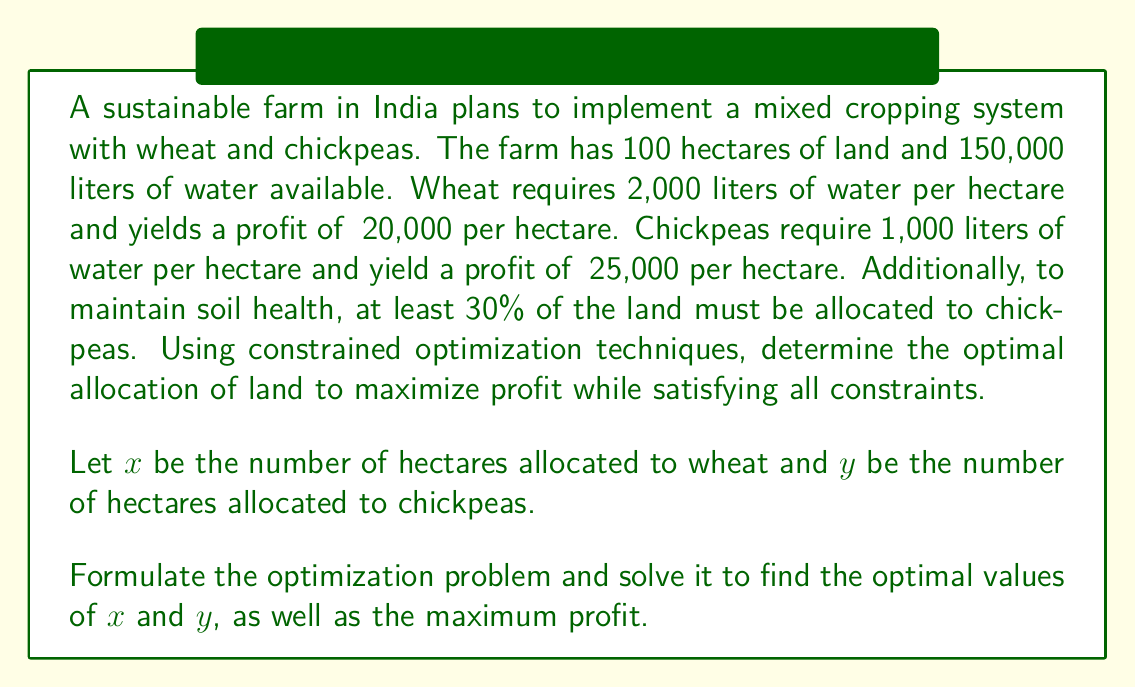Provide a solution to this math problem. To solve this problem, we'll use linear programming, a constrained optimization technique. Let's follow these steps:

1. Formulate the objective function:
   Maximize profit: $Z = 20000x + 25000y$

2. Identify the constraints:
   a) Land constraint: $x + y \leq 100$
   b) Water constraint: $2000x + 1000y \leq 150000$
   c) Chickpea minimum allocation: $y \geq 0.3(x + y)$, which simplifies to $0.7y \geq 0.3x$
   d) Non-negativity: $x \geq 0, y \geq 0$

3. Solve the linear programming problem:

   We can use the graphical method since we have only two variables.

   First, let's plot the constraints:

   a) $x + y = 100$
   b) $2x + y = 150$ (dividing the water constraint by 1000)
   c) $0.7y = 0.3x$, which simplifies to $y = \frac{3}{7}x$

   [asy]
   import geometry;

   size(200);
   
   real xmax = 100;
   real ymax = 100;
   
   draw((0,0)--(xmax,0)--(xmax,ymax)--(0,ymax)--cycle);
   
   draw((0,100)--(100,0), blue);
   draw((0,150)--(75,0), red);
   draw((0,0)--(100,42.86), green);
   
   label("$x + y = 100$", (50,50), SE, blue);
   label("$2x + y = 150$", (37.5,75), SE, red);
   label("$y = \frac{3}{7}x$", (50,21.43), NE, green);
   
   dot((60,40));
   label("A", (60,40), SE);
   dot((50,50));
   label("B", (50,50), NW);
   
   xaxis("x", 0, xmax, Arrow);
   yaxis("y", 0, ymax, Arrow);
   [/asy]

   The feasible region is the area bounded by these lines and the axes.

4. Identify the corner points:
   A: Intersection of $2x + y = 150$ and $y = \frac{3}{7}x$
      Solving: $2x + \frac{3}{7}x = 150$
               $\frac{17}{7}x = 150$
               $x = \frac{150 * 7}{17} \approx 61.76$
               $y = \frac{3}{7} * 61.76 \approx 26.47$
   
   B: Intersection of $x + y = 100$ and $y = \frac{3}{7}x$
      Solving: $x + \frac{3}{7}x = 100$
               $\frac{10}{7}x = 100$
               $x = 70$
               $y = 30$

5. Evaluate the objective function at these points:
   A: $Z = 20000(61.76) + 25000(26.47) \approx 1,897,050$
   B: $Z = 20000(70) + 25000(30) = 2,150,000$

The optimal solution is point B (70, 30), which satisfies all constraints and maximizes profit.
Answer: The optimal allocation is 70 hectares for wheat and 30 hectares for chickpeas, resulting in a maximum profit of ₹2,150,000. 